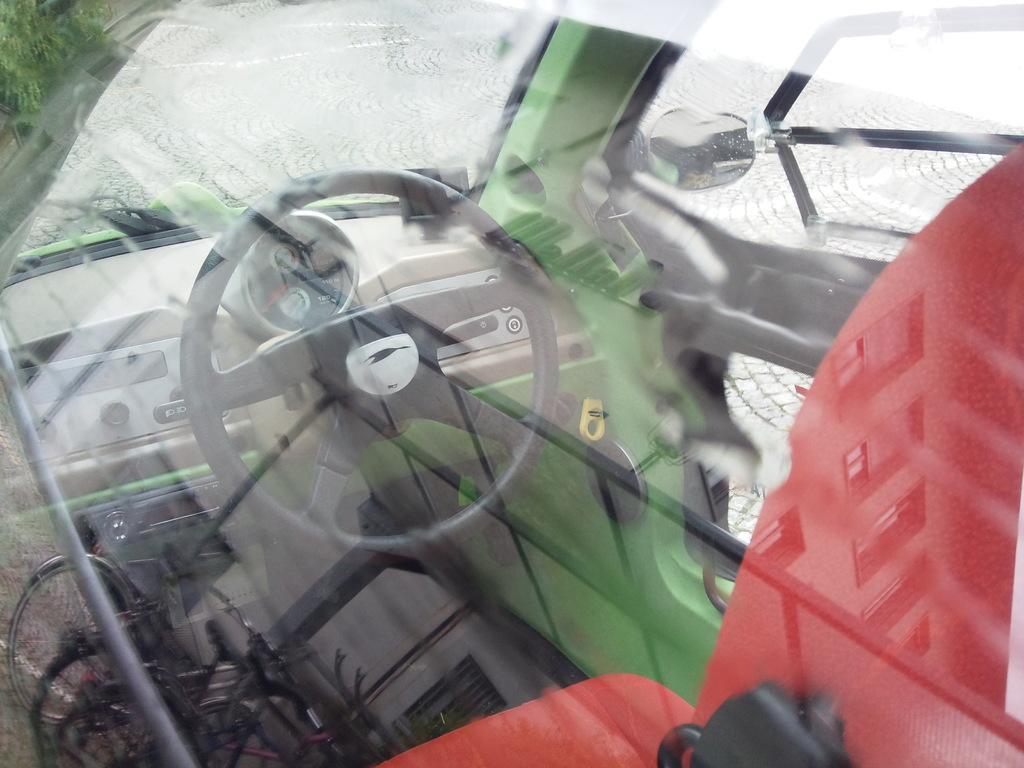How would you summarize this image in a sentence or two? This is an inside view of a vehicle. On the right side, I can see red color seat, in front of this I can see the steering. At the top I can see the glass and a mirror which is attached to this vehicle. 